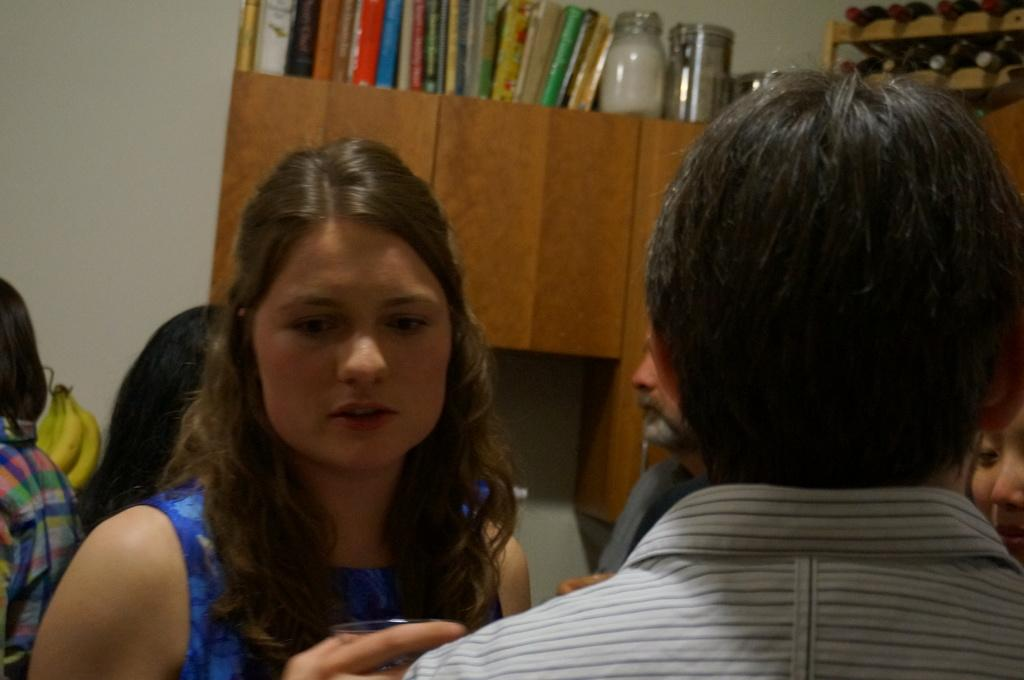<image>
Render a clear and concise summary of the photo. The back of a man and face of a woman standing in front of bookshelf with blurred text 